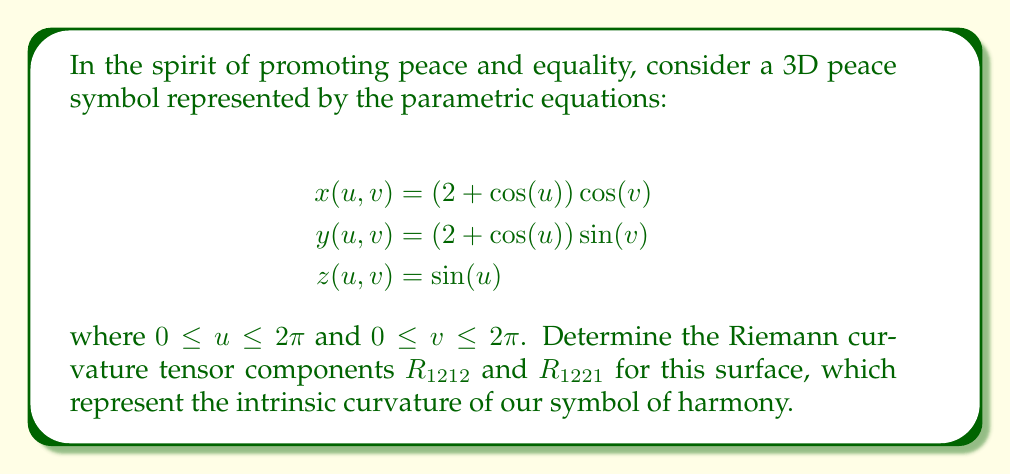Give your solution to this math problem. To find the Riemann curvature tensor components, we'll follow these steps:

1) First, calculate the metric tensor $g_{ij}$:
   $$g_{11} = E = (\frac{\partial x}{\partial u})^2 + (\frac{\partial y}{\partial u})^2 + (\frac{\partial z}{\partial u})^2 = \sin^2(u) + \cos^2(u) = 1$$
   $$g_{12} = g_{21} = F = \frac{\partial x}{\partial u}\frac{\partial x}{\partial v} + \frac{\partial y}{\partial u}\frac{\partial y}{\partial v} + \frac{\partial z}{\partial u}\frac{\partial z}{\partial v} = 0$$
   $$g_{22} = G = (\frac{\partial x}{\partial v})^2 + (\frac{\partial y}{\partial v})^2 + (\frac{\partial z}{\partial v})^2 = (2 + \cos(u))^2$$

2) Calculate the Christoffel symbols:
   $$\Gamma_{11}^1 = \Gamma_{12}^2 = \Gamma_{21}^2 = 0$$
   $$\Gamma_{11}^2 = \frac{\sin(u)}{2 + \cos(u)}$$
   $$\Gamma_{22}^1 = -(2 + \cos(u))\sin(u)$$
   $$\Gamma_{22}^2 = 0$$

3) Now, we can calculate the Riemann curvature tensor components:
   $$R_{1212} = \frac{\partial \Gamma_{12}^1}{\partial v} - \frac{\partial \Gamma_{11}^2}{\partial v} + \Gamma_{12}^k\Gamma_{k1}^1 - \Gamma_{11}^k\Gamma_{k2}^1$$
   $$R_{1212} = 0 - 0 + 0 - 0 = 0$$

   $$R_{1221} = \frac{\partial \Gamma_{22}^1}{\partial u} - \frac{\partial \Gamma_{21}^1}{\partial v} + \Gamma_{22}^k\Gamma_{k1}^1 - \Gamma_{21}^k\Gamma_{k2}^1$$
   $$R_{1221} = -\cos(u)\sin(u) - (2 + \cos(u))\cos(u) - 0 - 0 = -(2 + 2\cos(u))\cos(u)$$

4) The non-zero component $R_{1221}$ represents the intrinsic curvature of our peace symbol surface.
Answer: $R_{1212} = 0$, $R_{1221} = -(2 + 2\cos(u))\cos(u)$ 